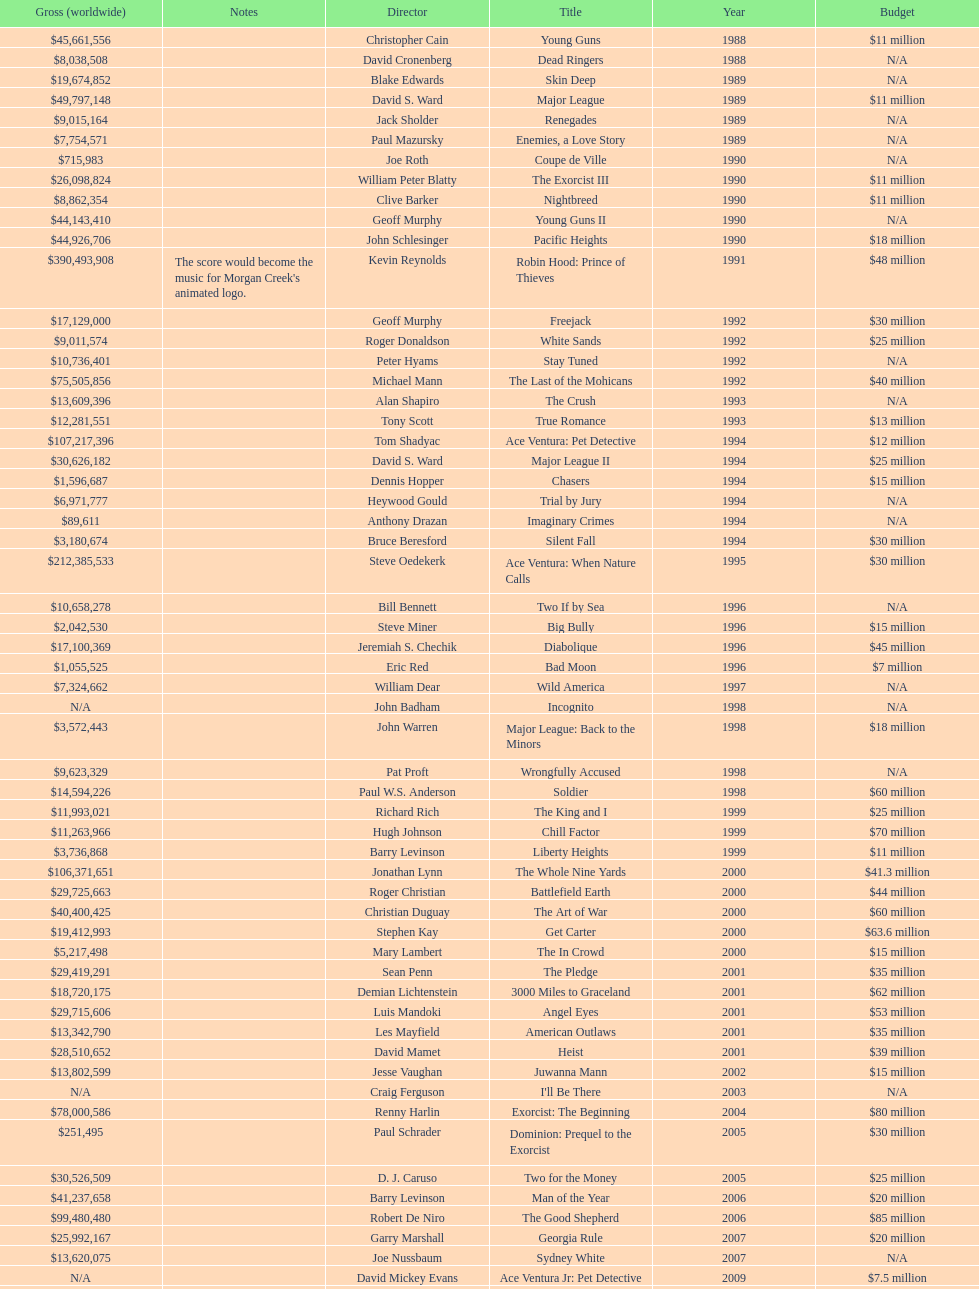What was the only movie with a 48 million dollar budget? Robin Hood: Prince of Thieves. 